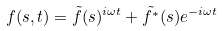Convert formula to latex. <formula><loc_0><loc_0><loc_500><loc_500>f ( s , t ) = \tilde { f } ( s ) ^ { i \omega t } + \tilde { f ^ { * } } ( s ) e ^ { - i \omega t }</formula> 